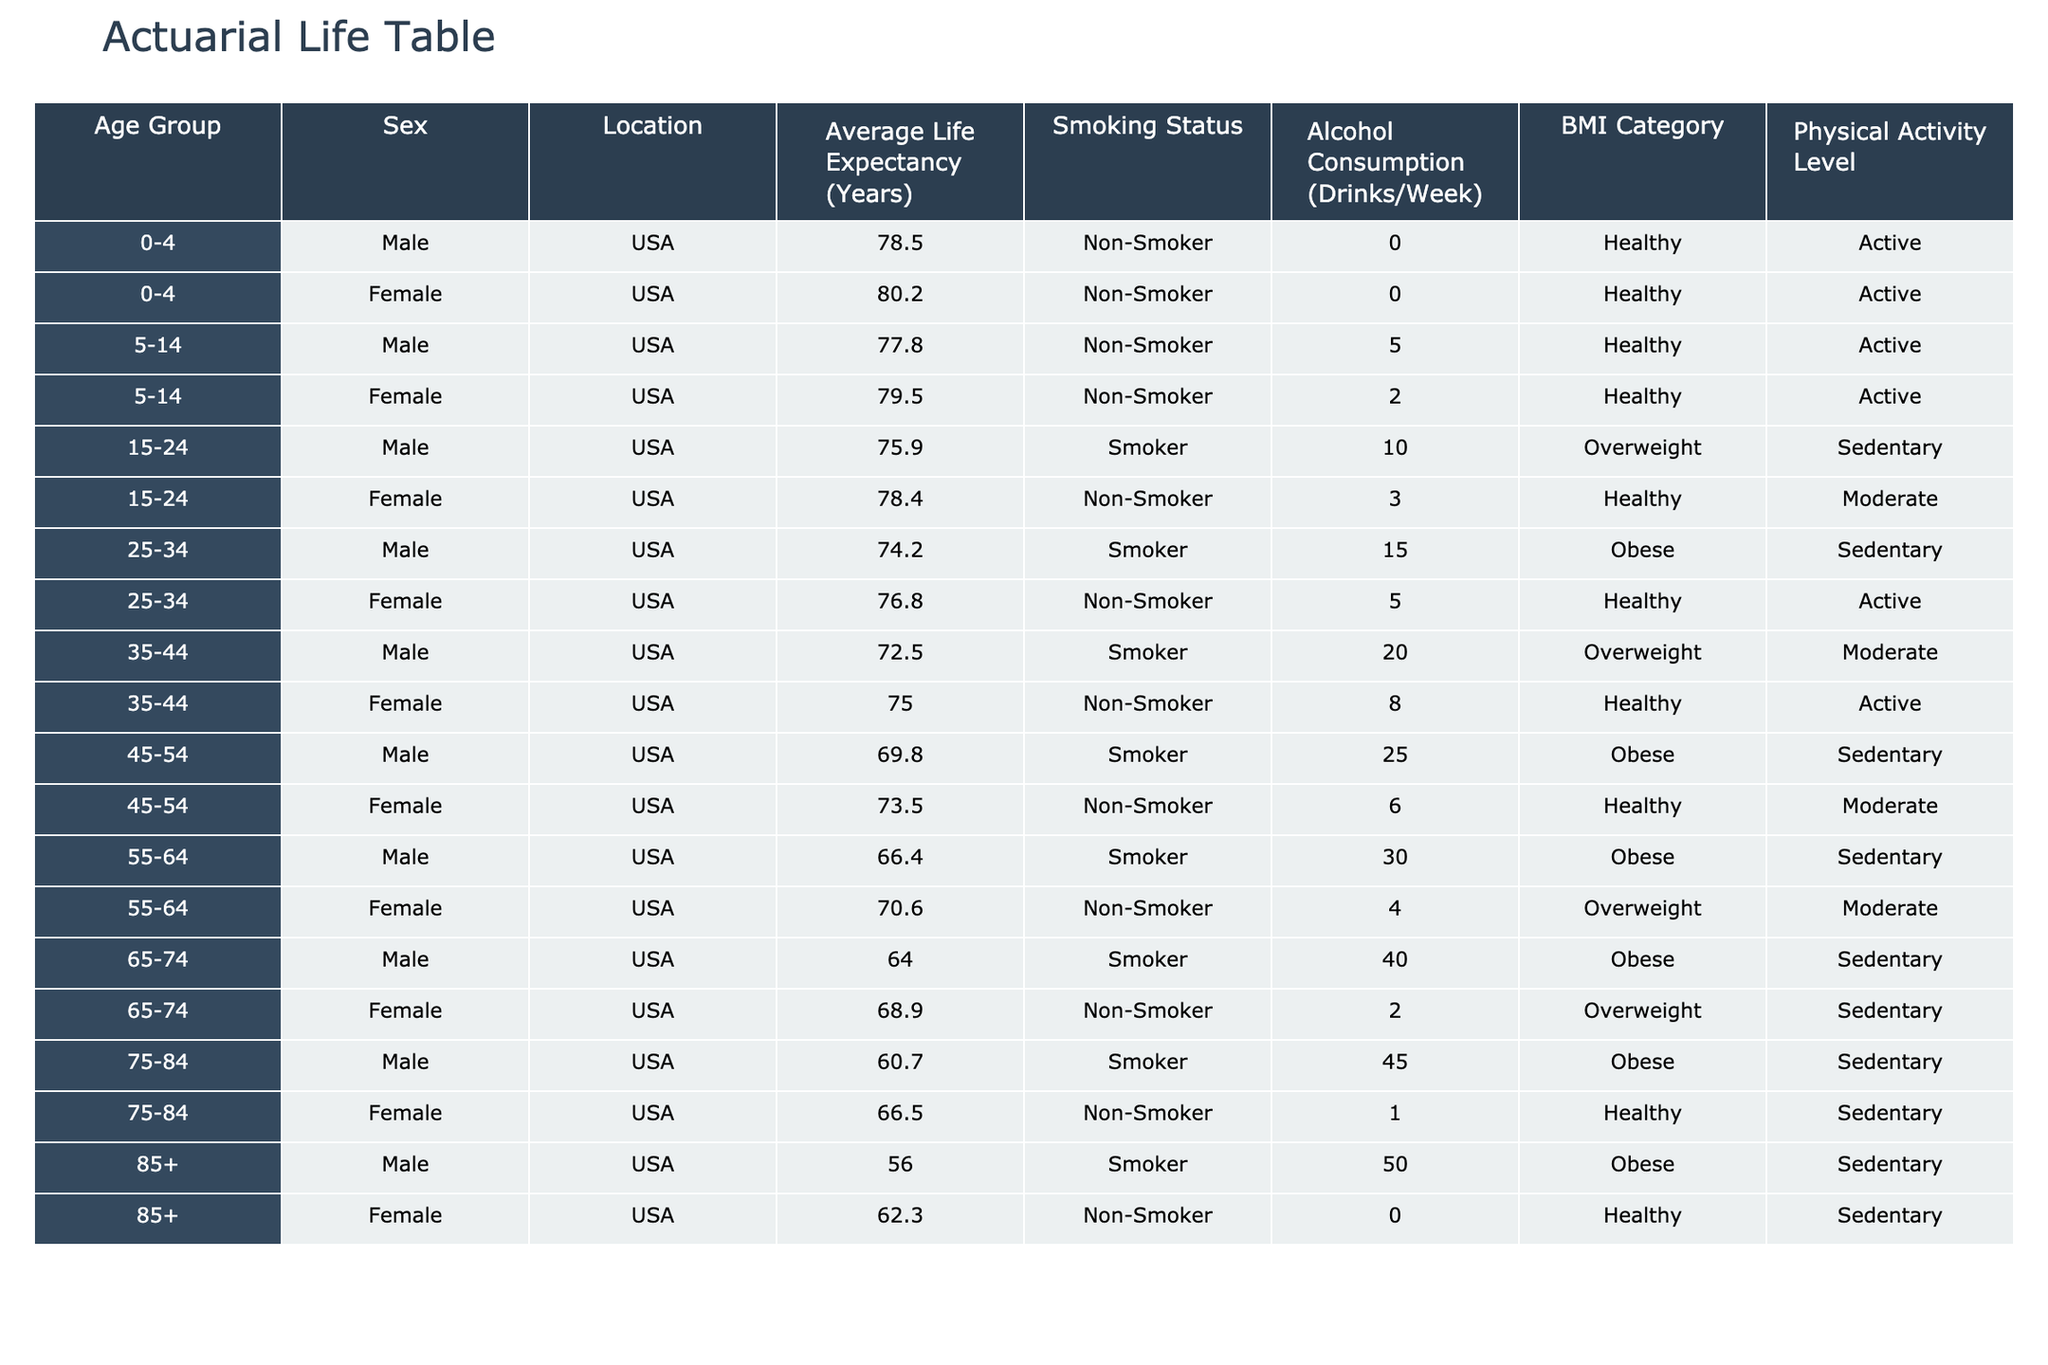What is the average life expectancy for males aged 25-34 in the USA? The life expectancy for males aged 25-34 in the USA, according to the table, is 74.2 years.
Answer: 74.2 How does the average life expectancy compare between males and females aged 55-64? For males aged 55-64, the life expectancy is 66.4 years, while for females it is 70.6 years. Females have a higher life expectancy by 4.2 years.
Answer: 4.2 years Is there a difference in life expectancy based on smoking status for the age group 15-24? Males who smoke have a life expectancy of 75.9 years, while females who do not smoke have a life expectancy of 78.4 years, indicating that non-smoking females live 2.5 years longer than smoking males.
Answer: Yes What is the life expectancy for females aged 35-44 who smoke? The table shows that females aged 35-44 who do not smoke have a life expectancy of 75.0 years, while there is no entry for smoking in this group, so we cannot provide a life expectancy for smoking females in this age group.
Answer: Not available What is the life expectancy of non-smokers aged 75-84 compared to smokers in the same age group? The life expectancy for non-smokers aged 75-84 is 66.5 years, while for smokers it is 60.7 years. Therefore, non-smokers live 5.8 years longer on average in this age group.
Answer: 5.8 years What is the average life expectancy for males across all age groups listed in the table? Summing the life expectancies of males: 78.5 + 77.8 + 75.9 + 74.2 + 72.5 + 69.8 + 66.4 + 64 + 60.7 + 56 =  605.8. There are 10 data points, so the average is 605.8 / 10 = 60.58 years.
Answer: 60.58 Are there any age groups where non-smokers have a lower life expectancy than smokers? In the provided data, non-smokers have a higher life expectancy than smokers across each age group listed; therefore, there's no age group meeting that criterion.
Answer: No What is the average Alcohol Consumption for all females listed in the table? Adding the alcohol consumption totals for females: 0 + 2 + 3 + 5 + 8 + 6 + 4 + 2 + 1 + 0 = 31 drinks. There are 10 data points, so the average is 31 / 10 = 3.1 drinks per week.
Answer: 3.1 drinks 